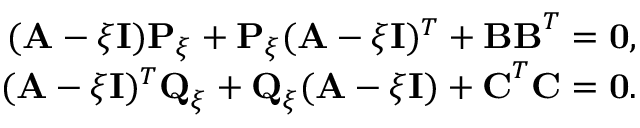<formula> <loc_0><loc_0><loc_500><loc_500>\begin{array} { r } { ( { A } - { \xi } { I } ) { P } _ { \xi } + { P } _ { \xi } ( { A } - { \xi } { I } ) ^ { T } + { B } { B } ^ { T } = { 0 } , } \\ { ( { A } - { \xi } { I } ) ^ { T } { Q } _ { \xi } + { Q } _ { \xi } ( { A } - { \xi } { I } ) + { C } ^ { T } { C } = { 0 } . } \end{array}</formula> 